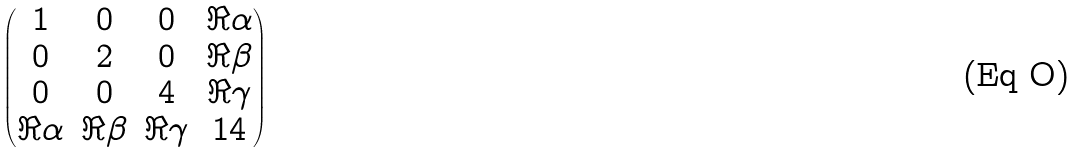Convert formula to latex. <formula><loc_0><loc_0><loc_500><loc_500>\begin{pmatrix} 1 & 0 & 0 & \Re { \alpha } \\ 0 & 2 & 0 & \Re { \beta } \\ 0 & 0 & 4 & \Re { \gamma } \\ \Re { \alpha } & \Re { \beta } & \Re { \gamma } & 1 4 \end{pmatrix}</formula> 